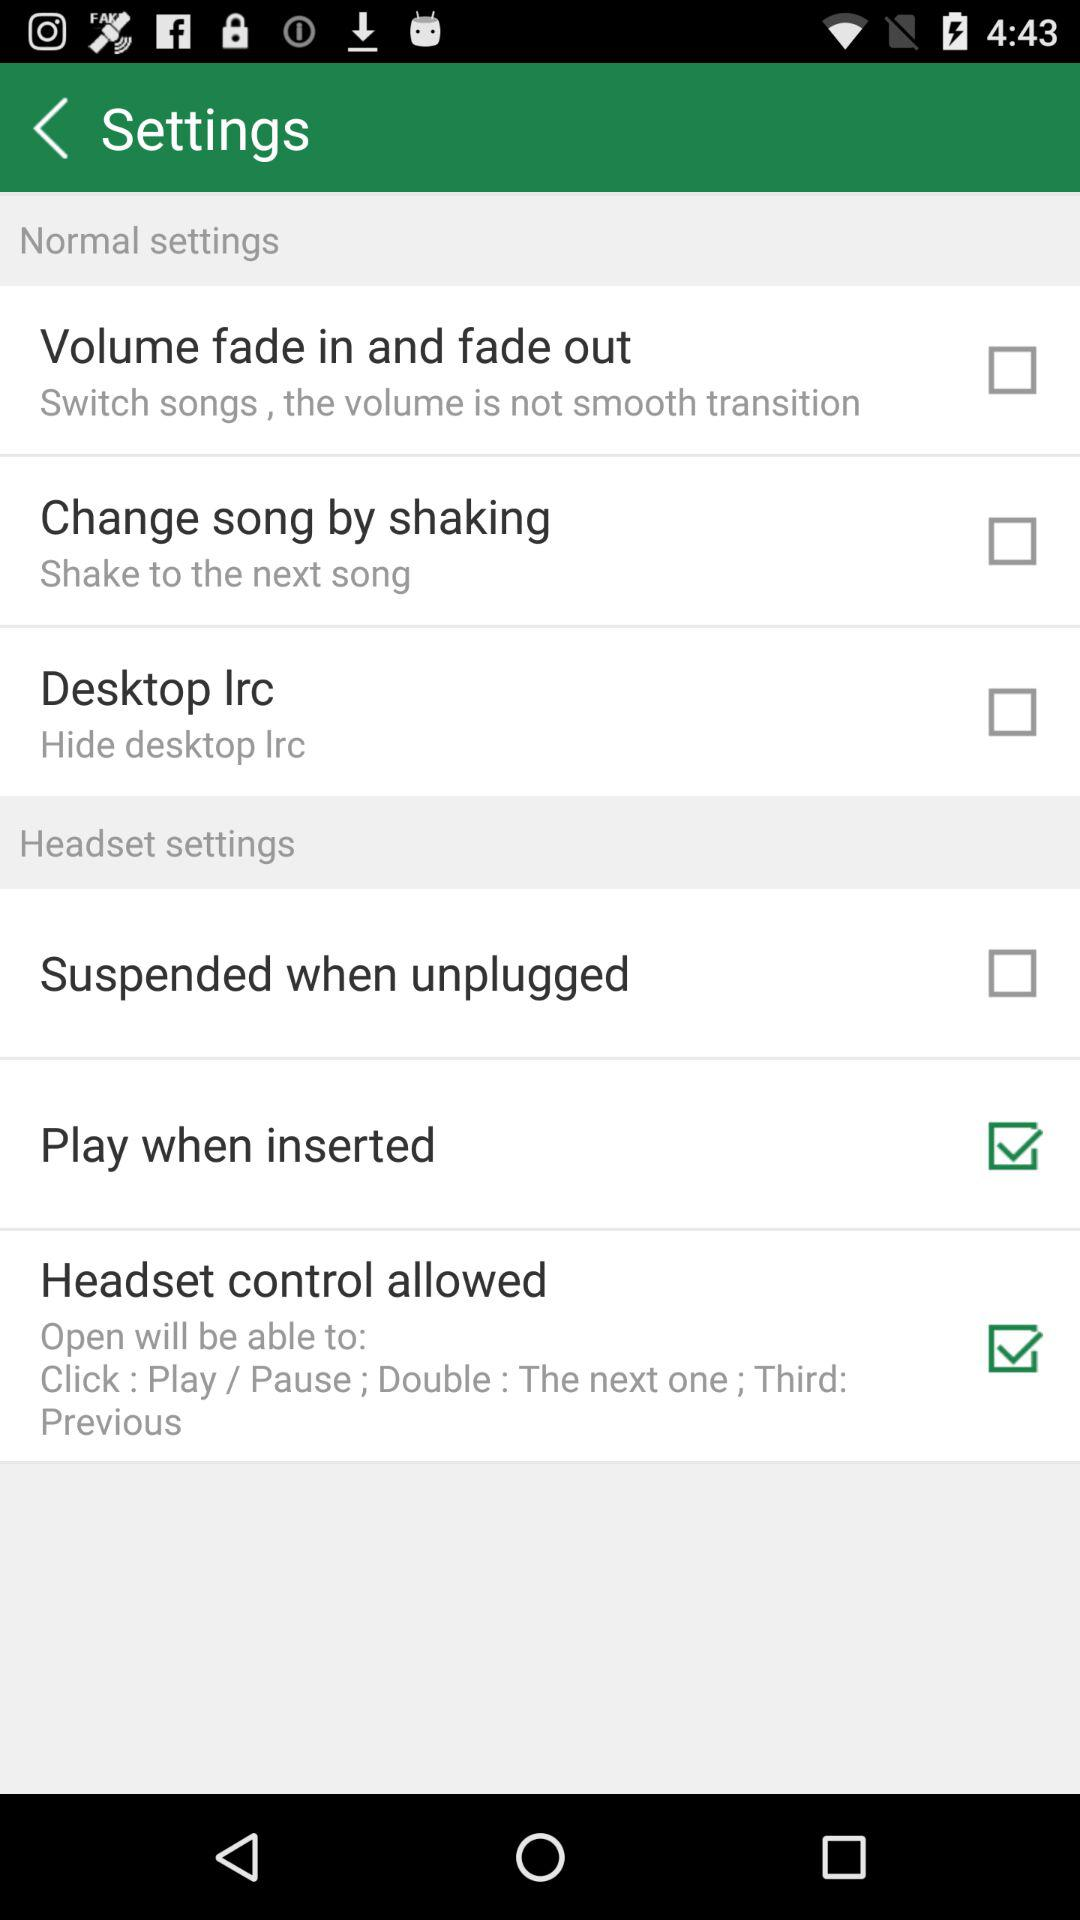How many items are in the headset settings section?
Answer the question using a single word or phrase. 3 